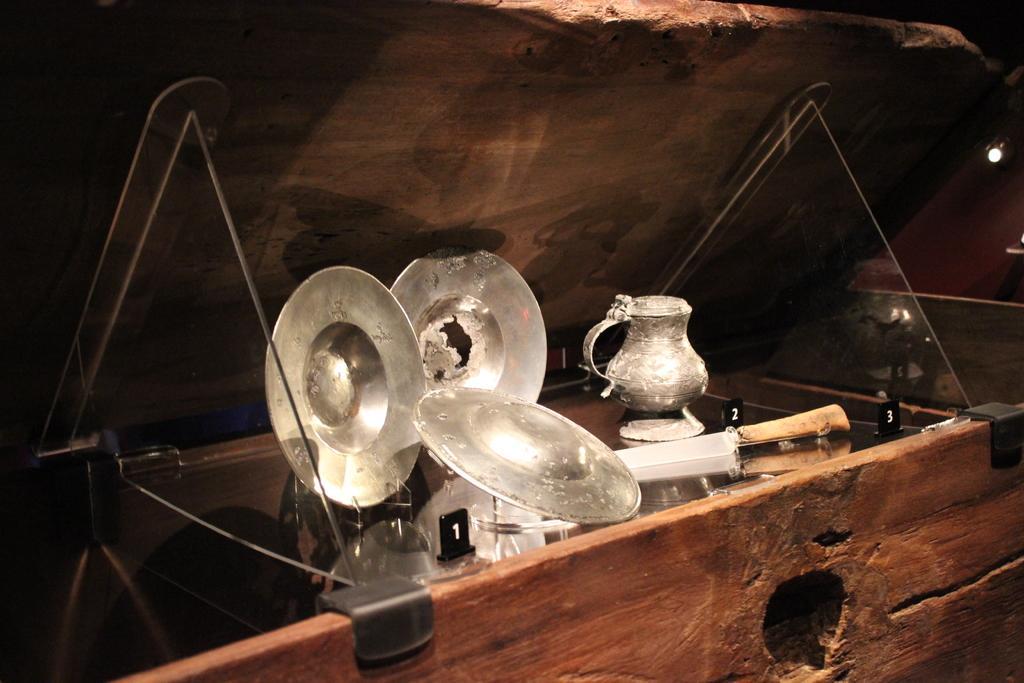Can you describe this image briefly? In this image we can see a box. In the box there are plates, jar and few objects. Right side, we can see a light. 